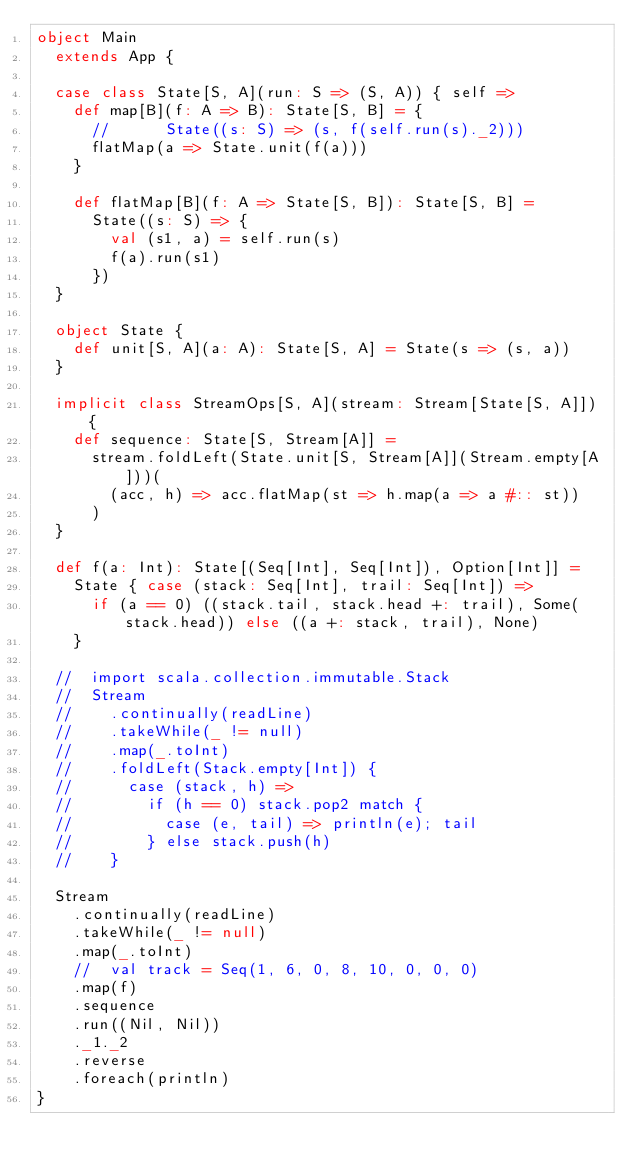Convert code to text. <code><loc_0><loc_0><loc_500><loc_500><_Scala_>object Main
  extends App {

  case class State[S, A](run: S => (S, A)) { self =>
    def map[B](f: A => B): State[S, B] = {
      //      State((s: S) => (s, f(self.run(s)._2)))
      flatMap(a => State.unit(f(a)))
    }

    def flatMap[B](f: A => State[S, B]): State[S, B] =
      State((s: S) => {
        val (s1, a) = self.run(s)
        f(a).run(s1)
      })
  }

  object State {
    def unit[S, A](a: A): State[S, A] = State(s => (s, a))
  }

  implicit class StreamOps[S, A](stream: Stream[State[S, A]]) {
    def sequence: State[S, Stream[A]] =
      stream.foldLeft(State.unit[S, Stream[A]](Stream.empty[A]))(
        (acc, h) => acc.flatMap(st => h.map(a => a #:: st))
      )
  }

  def f(a: Int): State[(Seq[Int], Seq[Int]), Option[Int]] =
    State { case (stack: Seq[Int], trail: Seq[Int]) =>
      if (a == 0) ((stack.tail, stack.head +: trail), Some(stack.head)) else ((a +: stack, trail), None)
    }

  //  import scala.collection.immutable.Stack
  //  Stream
  //    .continually(readLine)
  //    .takeWhile(_ != null)
  //    .map(_.toInt)
  //    .foldLeft(Stack.empty[Int]) {
  //      case (stack, h) =>
  //        if (h == 0) stack.pop2 match {
  //          case (e, tail) => println(e); tail
  //        } else stack.push(h)
  //    }

  Stream
    .continually(readLine)
    .takeWhile(_ != null)
    .map(_.toInt)
    //  val track = Seq(1, 6, 0, 8, 10, 0, 0, 0)
    .map(f)
    .sequence
    .run((Nil, Nil))
    ._1._2
    .reverse
    .foreach(println)
}
</code> 